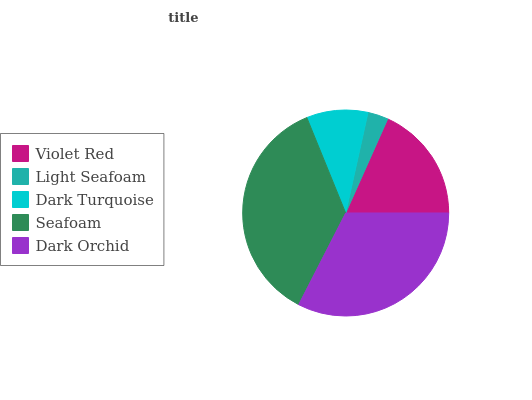Is Light Seafoam the minimum?
Answer yes or no. Yes. Is Seafoam the maximum?
Answer yes or no. Yes. Is Dark Turquoise the minimum?
Answer yes or no. No. Is Dark Turquoise the maximum?
Answer yes or no. No. Is Dark Turquoise greater than Light Seafoam?
Answer yes or no. Yes. Is Light Seafoam less than Dark Turquoise?
Answer yes or no. Yes. Is Light Seafoam greater than Dark Turquoise?
Answer yes or no. No. Is Dark Turquoise less than Light Seafoam?
Answer yes or no. No. Is Violet Red the high median?
Answer yes or no. Yes. Is Violet Red the low median?
Answer yes or no. Yes. Is Dark Orchid the high median?
Answer yes or no. No. Is Light Seafoam the low median?
Answer yes or no. No. 